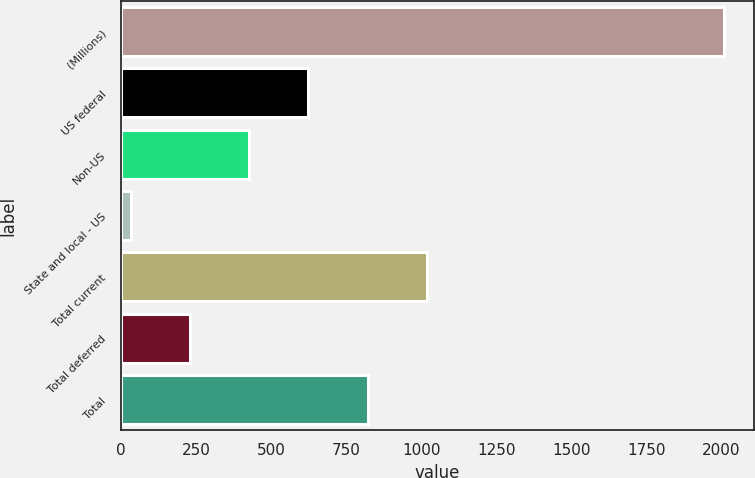Convert chart. <chart><loc_0><loc_0><loc_500><loc_500><bar_chart><fcel>(Millions)<fcel>US federal<fcel>Non-US<fcel>State and local - US<fcel>Total current<fcel>Total deferred<fcel>Total<nl><fcel>2007<fcel>623.8<fcel>426.2<fcel>31<fcel>1019<fcel>228.6<fcel>821.4<nl></chart> 